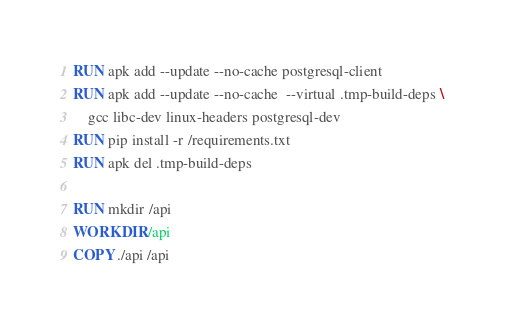<code> <loc_0><loc_0><loc_500><loc_500><_Dockerfile_>RUN apk add --update --no-cache postgresql-client
RUN apk add --update --no-cache  --virtual .tmp-build-deps \
    gcc libc-dev linux-headers postgresql-dev
RUN pip install -r /requirements.txt
RUN apk del .tmp-build-deps

RUN mkdir /api
WORKDIR /api
COPY ./api /api
</code> 